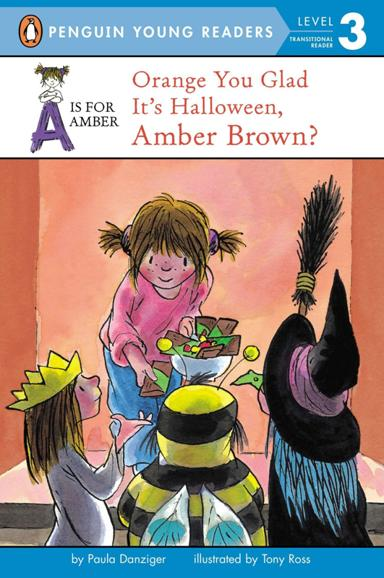What is the title of the book mentioned in the image? The book showcased in the image is titled "Orange You Glad It's Halloween, Amber Brown." This engaging children's story is part of the beloved Amber Brown series, known for its charming and relatable narratives. 